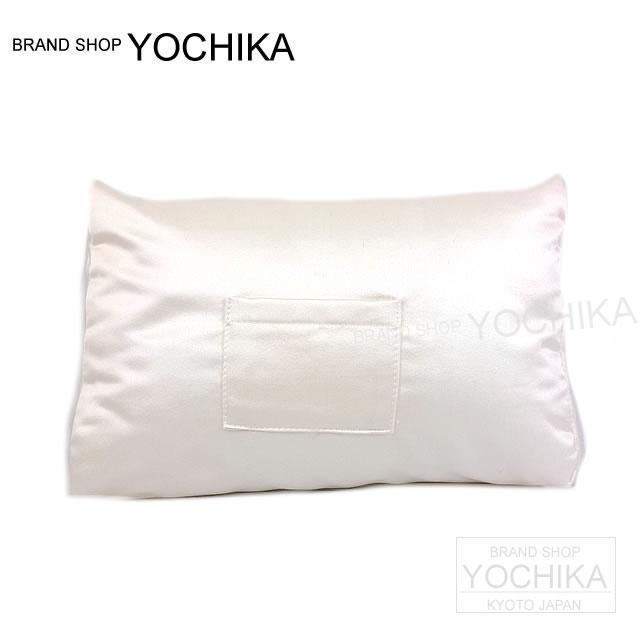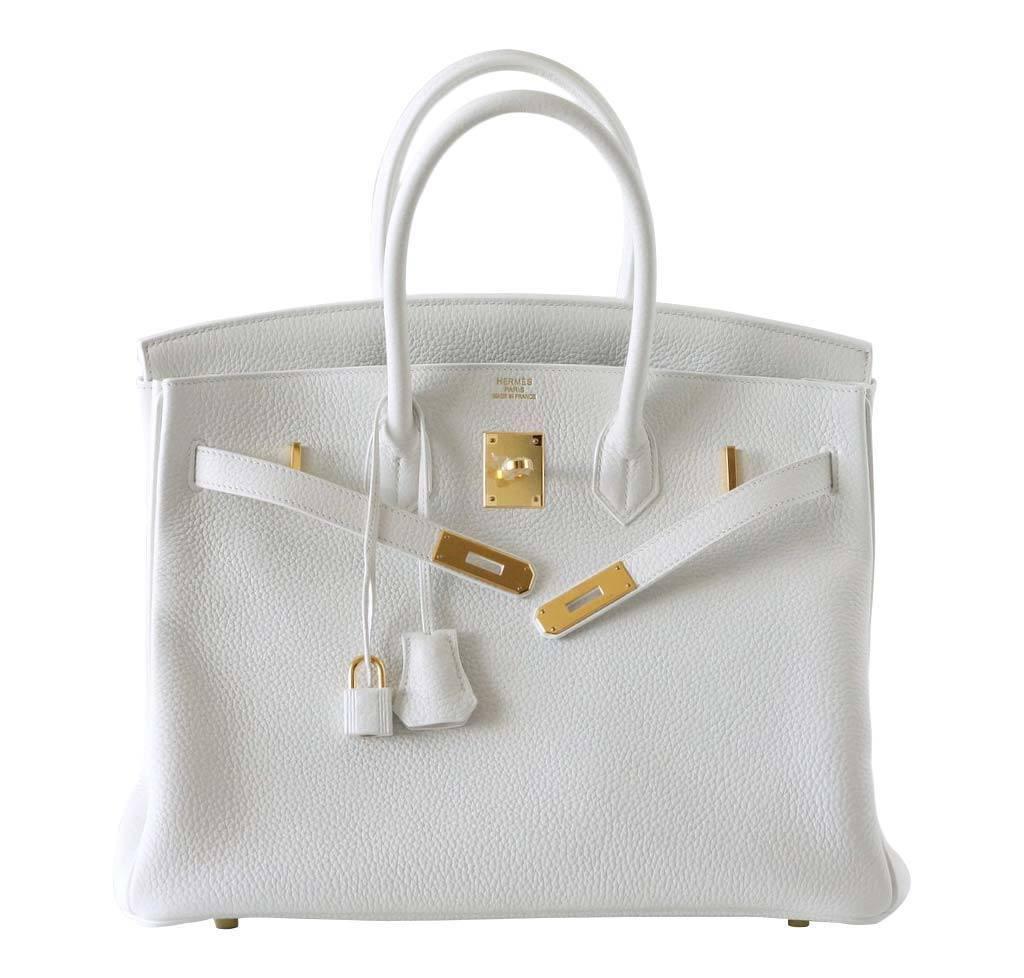The first image is the image on the left, the second image is the image on the right. Analyze the images presented: Is the assertion "The right image shows an upright coral-colored handbag to the left of an upright tan handbag, and a white wedge pillow is in front of them." valid? Answer yes or no. No. The first image is the image on the left, the second image is the image on the right. For the images displayed, is the sentence "The image on the right shows two purses and a purse pillow." factually correct? Answer yes or no. No. 